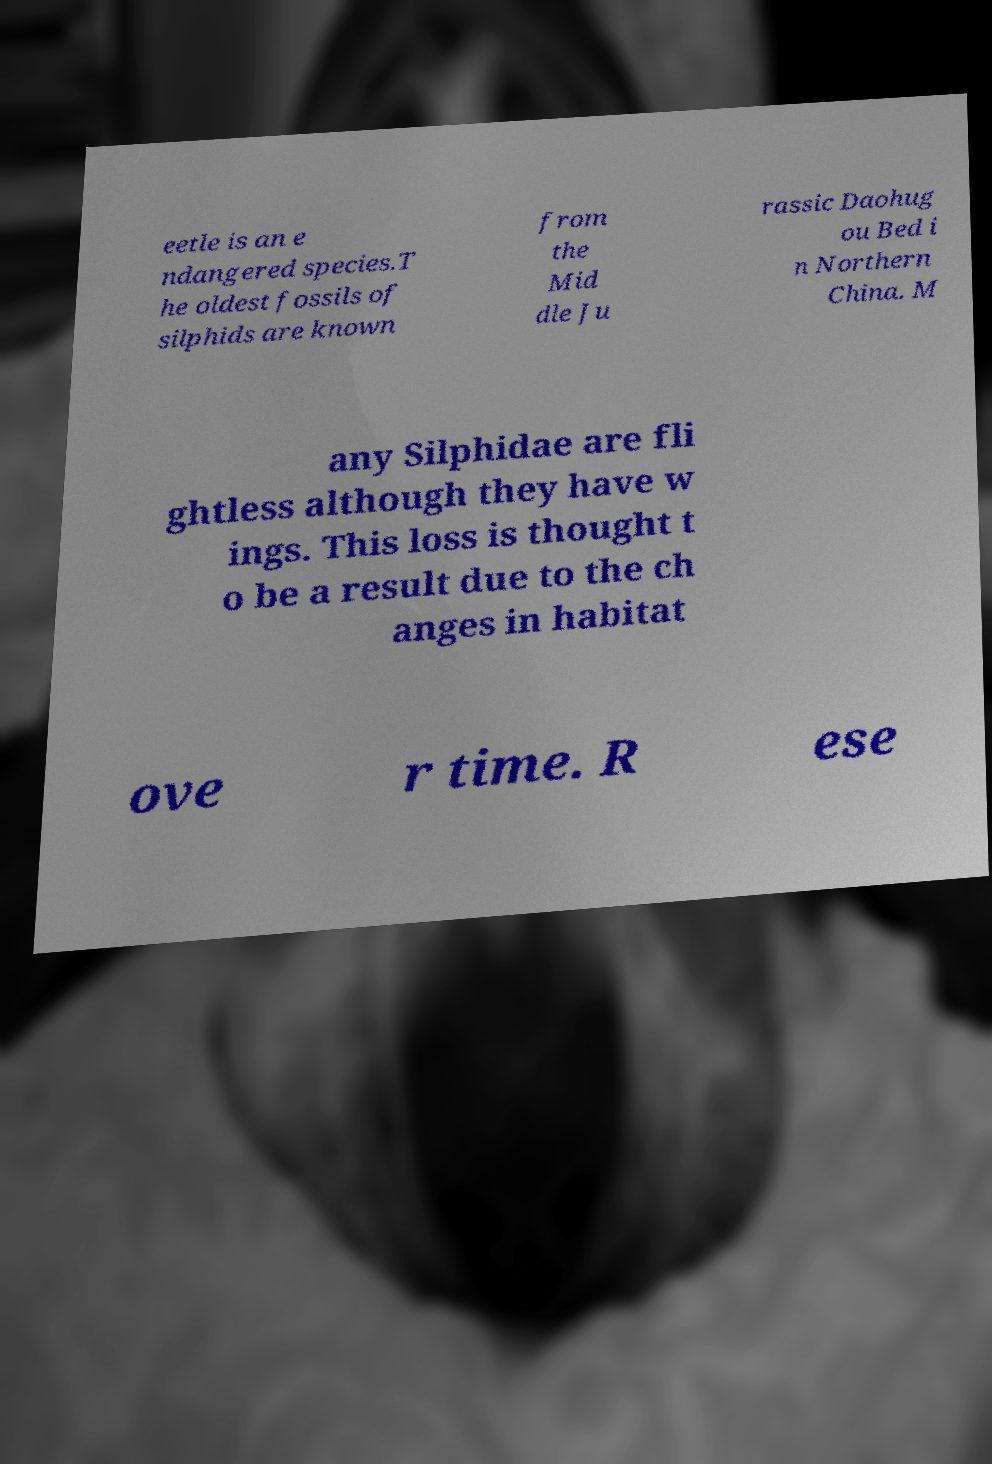Please read and relay the text visible in this image. What does it say? eetle is an e ndangered species.T he oldest fossils of silphids are known from the Mid dle Ju rassic Daohug ou Bed i n Northern China. M any Silphidae are fli ghtless although they have w ings. This loss is thought t o be a result due to the ch anges in habitat ove r time. R ese 